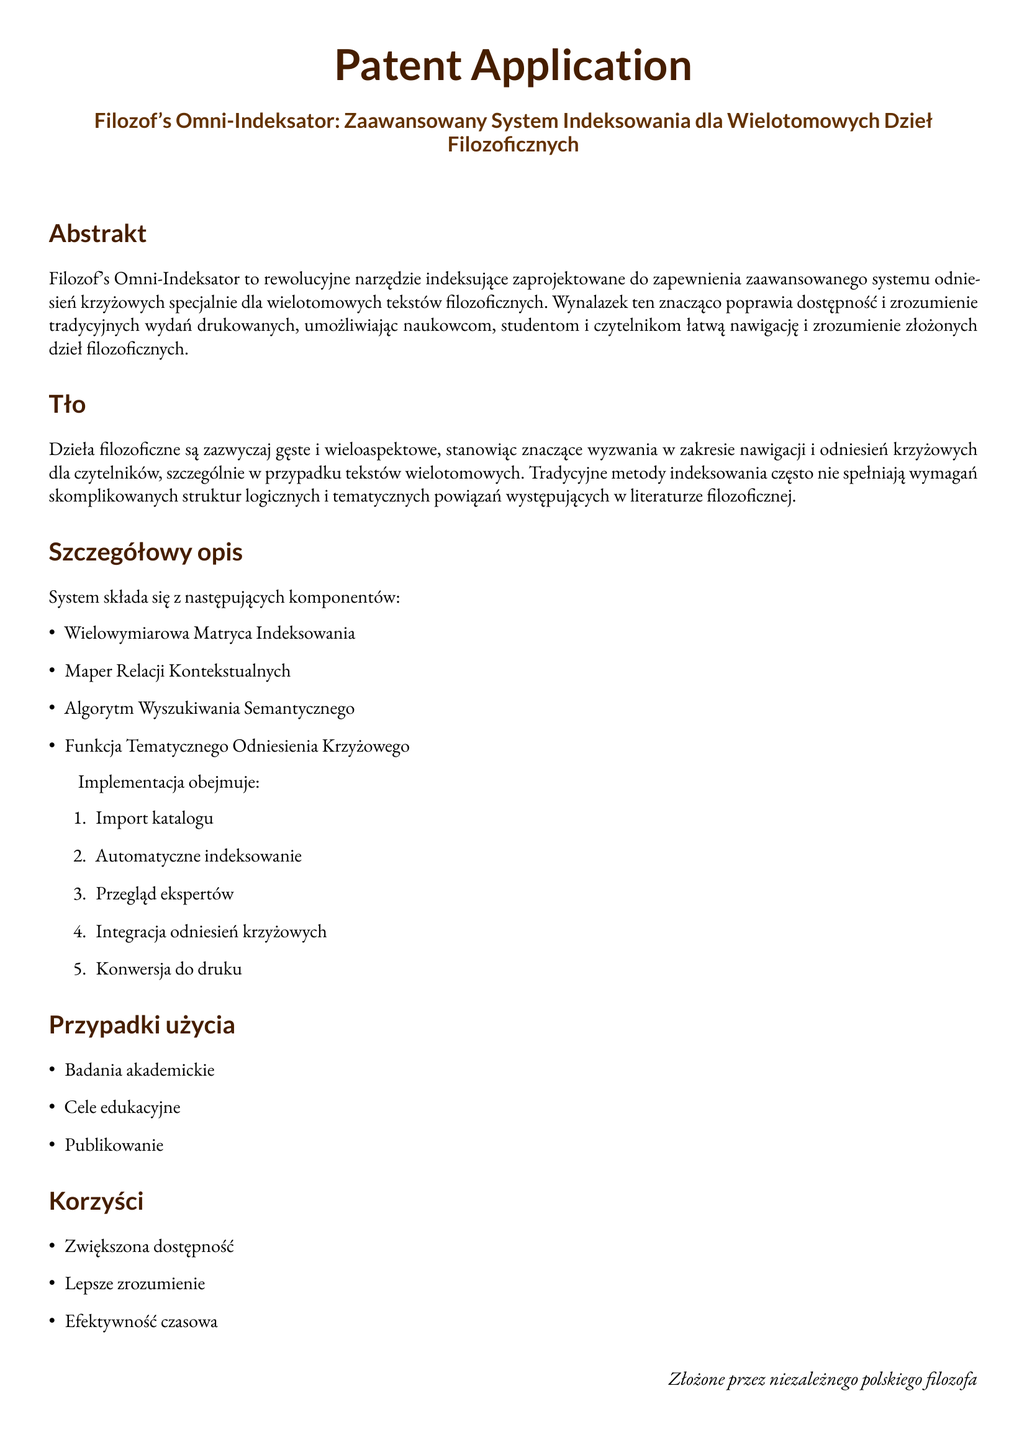What is the title of the patent application? The title is found prominently near the beginning of the document.
Answer: Filozof's Omni-Indeksator: Zaawansowany System Indeksowania dla Wielotomowych Dzieł Filozoficznych What is the main benefit of the Philosopher's Omni-Indexer? The benefits are listed in a specific section of the document, highlighting the advantages of the system.
Answer: Zwiększona dostępność How many components are in the system? The document lists the components in a bullet point format.
Answer: cztery What are the implementation steps mentioned in the application? The steps for implementation are provided in an enumerated list in the detailed description section.
Answer: Import katalogu, automatyczne indeksowanie, przegląd ekspertów, integracja odniesień krzyżowych, konwersja do druku What specific field does the invention target? The background section describes the context in which the invention operates, focusing on a particular area of literature.
Answer: Dzieła filozoficzne Who is the inventor of the Philosopher's Omni-Indexer? The document attributes the patent application to a specific individual as stated at the bottom.
Answer: niezależny polski filozof What is the usage case listed under academic studies? The application mentions how the technology can be used specifically within academic contexts.
Answer: Badania akademickie What does the Semantic Search Algorithm relate to? The detailed description section reveals the components of the indexing system, explaining how they are interconnected.
Answer: Relacji Kontekstualnych 